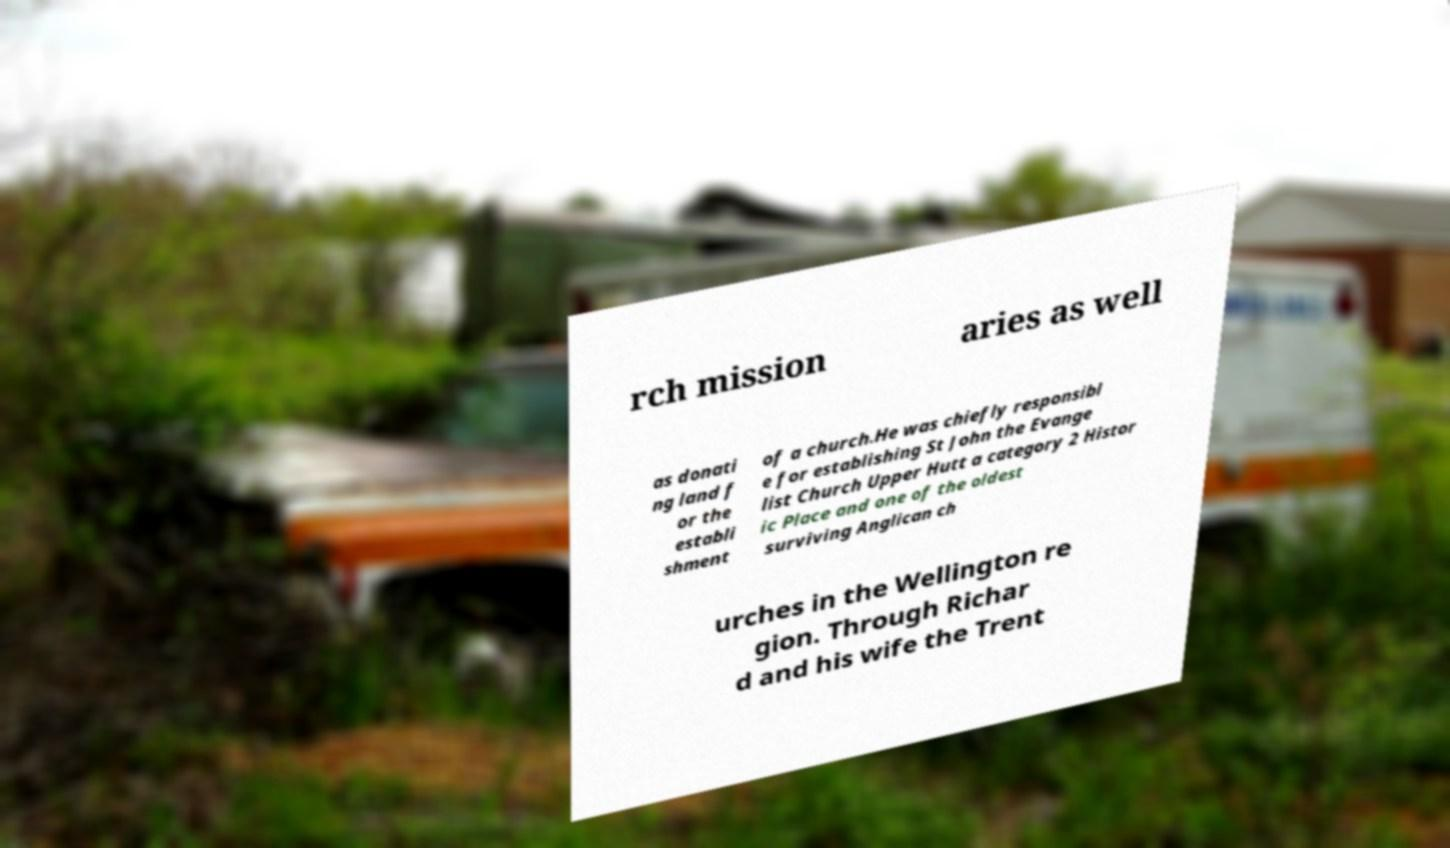Can you read and provide the text displayed in the image?This photo seems to have some interesting text. Can you extract and type it out for me? rch mission aries as well as donati ng land f or the establi shment of a church.He was chiefly responsibl e for establishing St John the Evange list Church Upper Hutt a category 2 Histor ic Place and one of the oldest surviving Anglican ch urches in the Wellington re gion. Through Richar d and his wife the Trent 